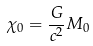<formula> <loc_0><loc_0><loc_500><loc_500>\chi _ { 0 } = \frac { G } { c ^ { 2 } } M _ { 0 }</formula> 